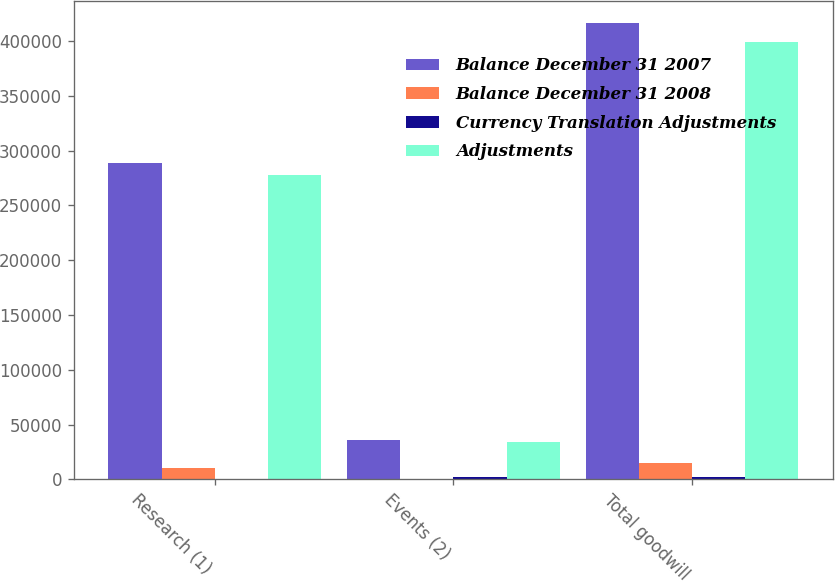Convert chart. <chart><loc_0><loc_0><loc_500><loc_500><stacked_bar_chart><ecel><fcel>Research (1)<fcel>Events (2)<fcel>Total goodwill<nl><fcel>Balance December 31 2007<fcel>289199<fcel>36475<fcel>416181<nl><fcel>Balance December 31 2008<fcel>10600<fcel>107<fcel>15084<nl><fcel>Currency Translation Adjustments<fcel>520<fcel>1840<fcel>2360<nl><fcel>Adjustments<fcel>278079<fcel>34528<fcel>398737<nl></chart> 